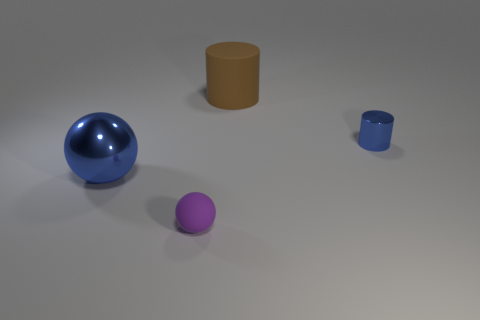Can you describe the positioning of the objects relative to each other? In the image, the objects are spaced out on a flat surface. The large glossy blue sphere is positioned towards the back and to the right. In the foreground to the left is a small matte purple sphere, and to its right, there is a matte beige cylinder. A smaller shiny blue cylinder is placed further right and slightly behind the beige cylinder, aligning diagonally back towards the large sphere.  What might be the purpose of arranging these objects in this manner? The arrangement appears to be designed with visual balance and aesthetic in mind, possibly for an artistic composition or to study the effects of light on different surfaces and colors. The variation in size, color, and material creates a visually engaging tableau that can evoke curiosity about the properties of objects and how they interact with their environment. 